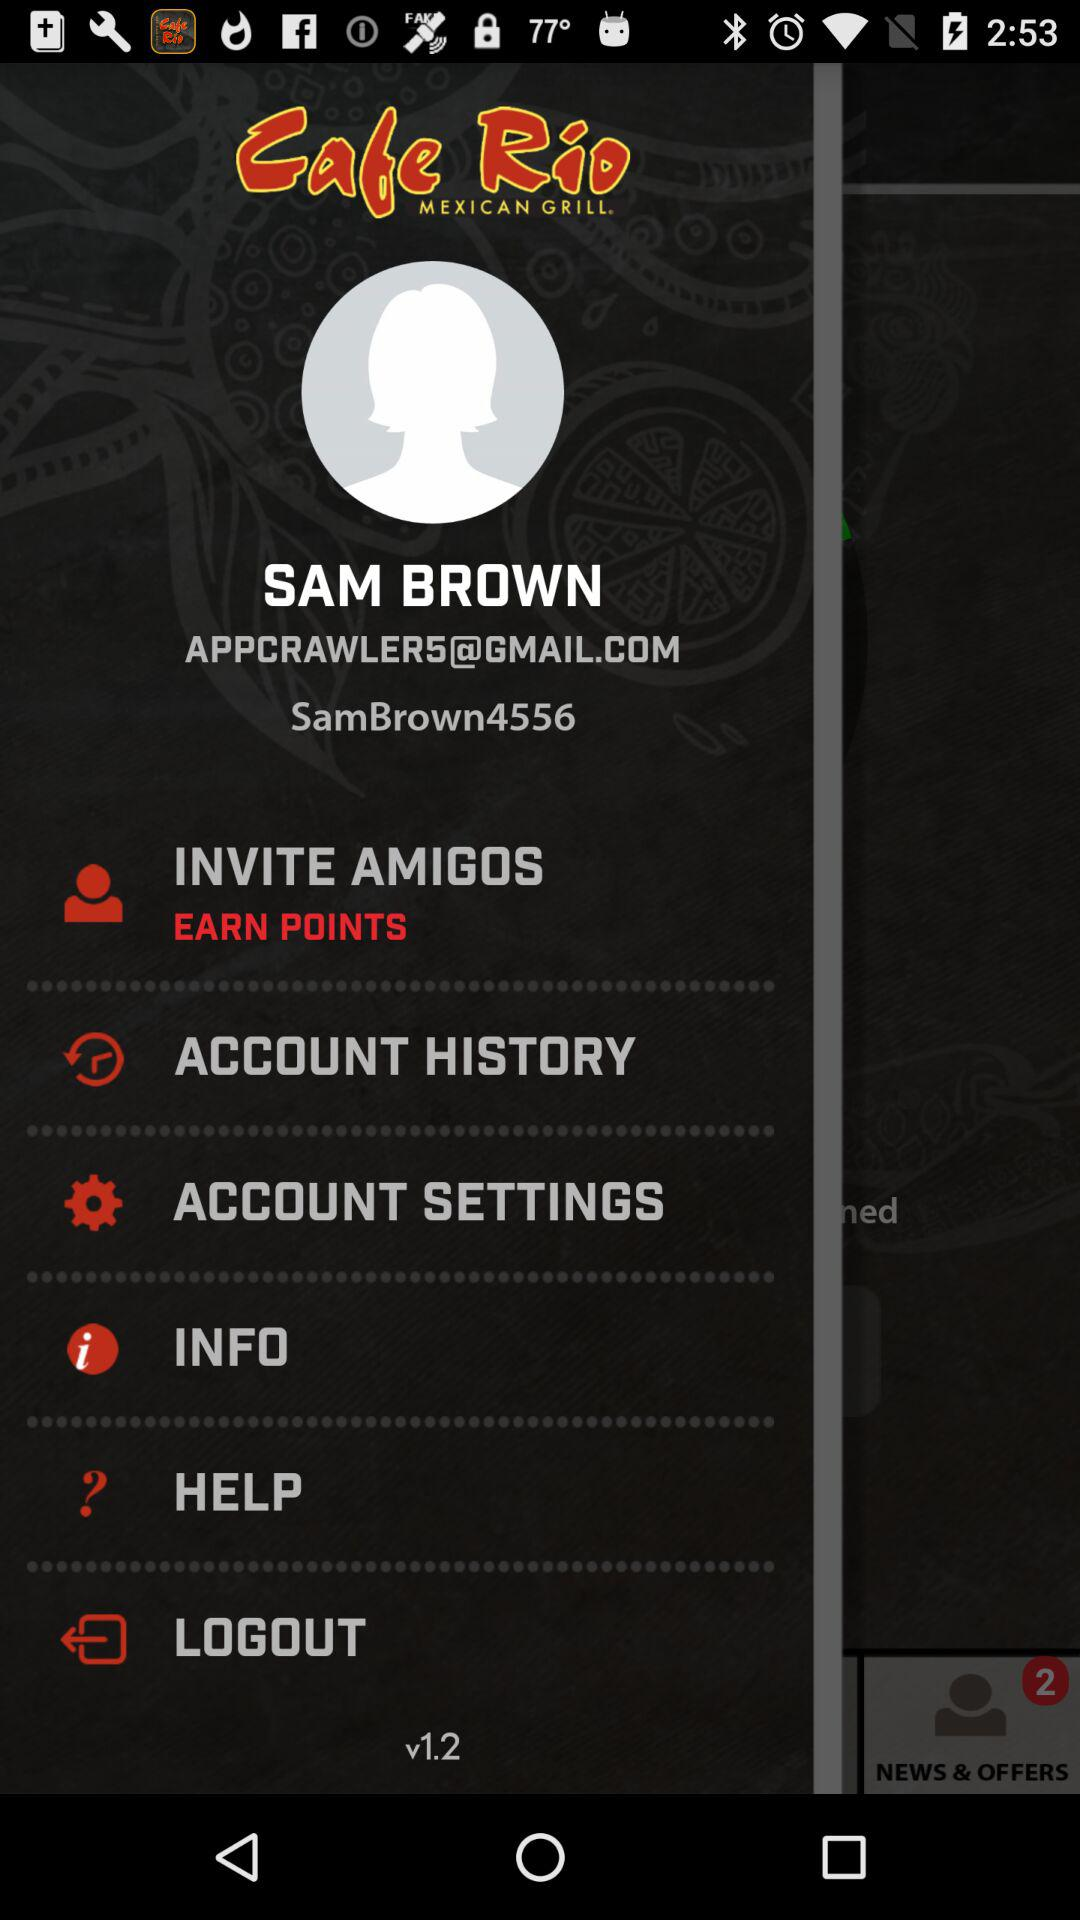What is the name of the application? The application name is "Cafe Rio MEXICAN GRILL". 